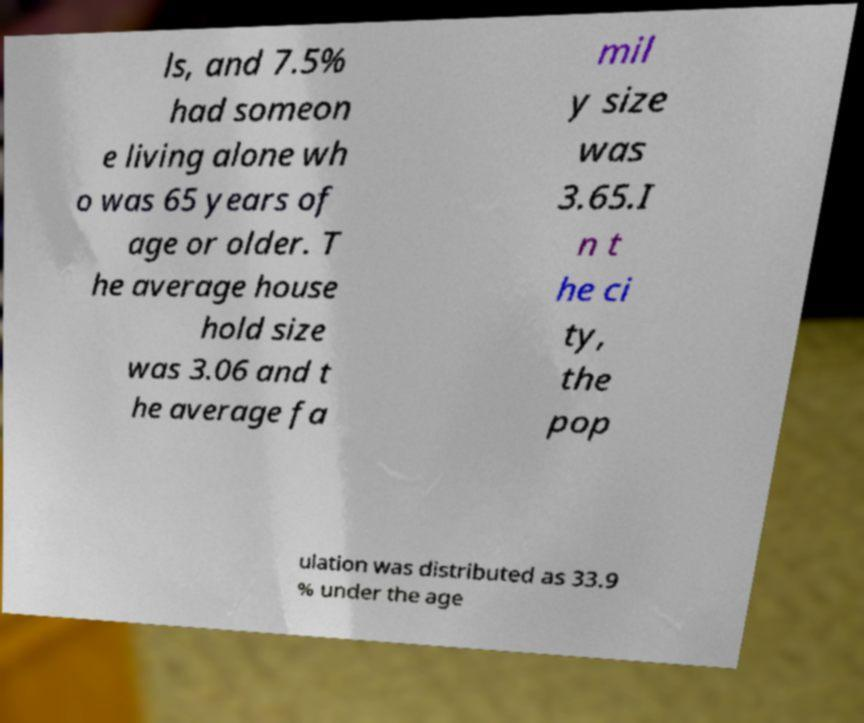What messages or text are displayed in this image? I need them in a readable, typed format. ls, and 7.5% had someon e living alone wh o was 65 years of age or older. T he average house hold size was 3.06 and t he average fa mil y size was 3.65.I n t he ci ty, the pop ulation was distributed as 33.9 % under the age 